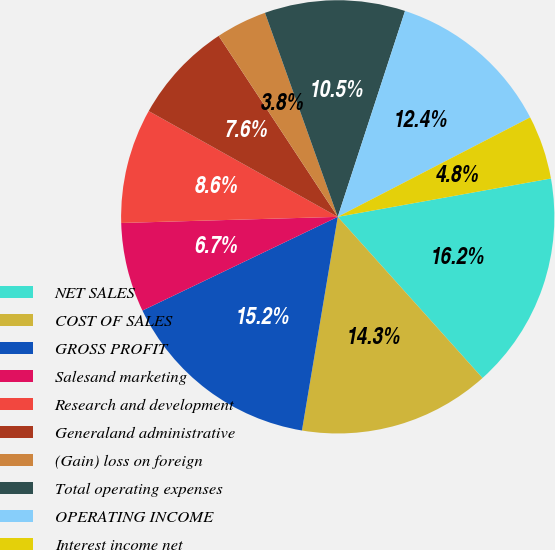<chart> <loc_0><loc_0><loc_500><loc_500><pie_chart><fcel>NET SALES<fcel>COST OF SALES<fcel>GROSS PROFIT<fcel>Salesand marketing<fcel>Research and development<fcel>Generaland administrative<fcel>(Gain) loss on foreign<fcel>Total operating expenses<fcel>OPERATING INCOME<fcel>Interest income net<nl><fcel>16.19%<fcel>14.29%<fcel>15.24%<fcel>6.67%<fcel>8.57%<fcel>7.62%<fcel>3.81%<fcel>10.48%<fcel>12.38%<fcel>4.76%<nl></chart> 